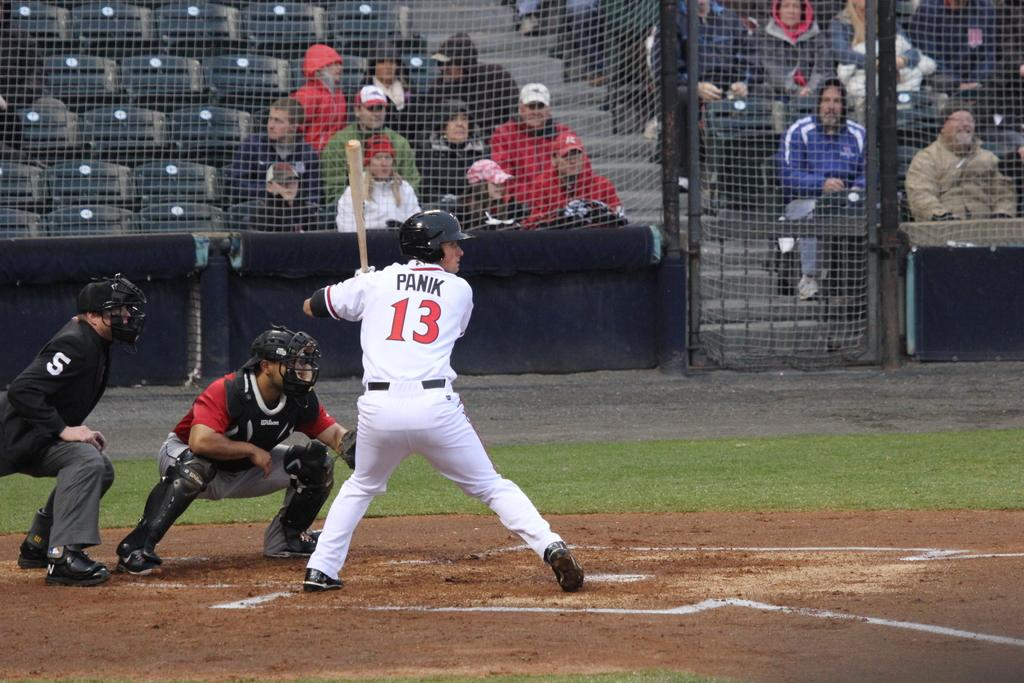<image>
Share a concise interpretation of the image provided. Panik at the plate getting ready to swing a bat 